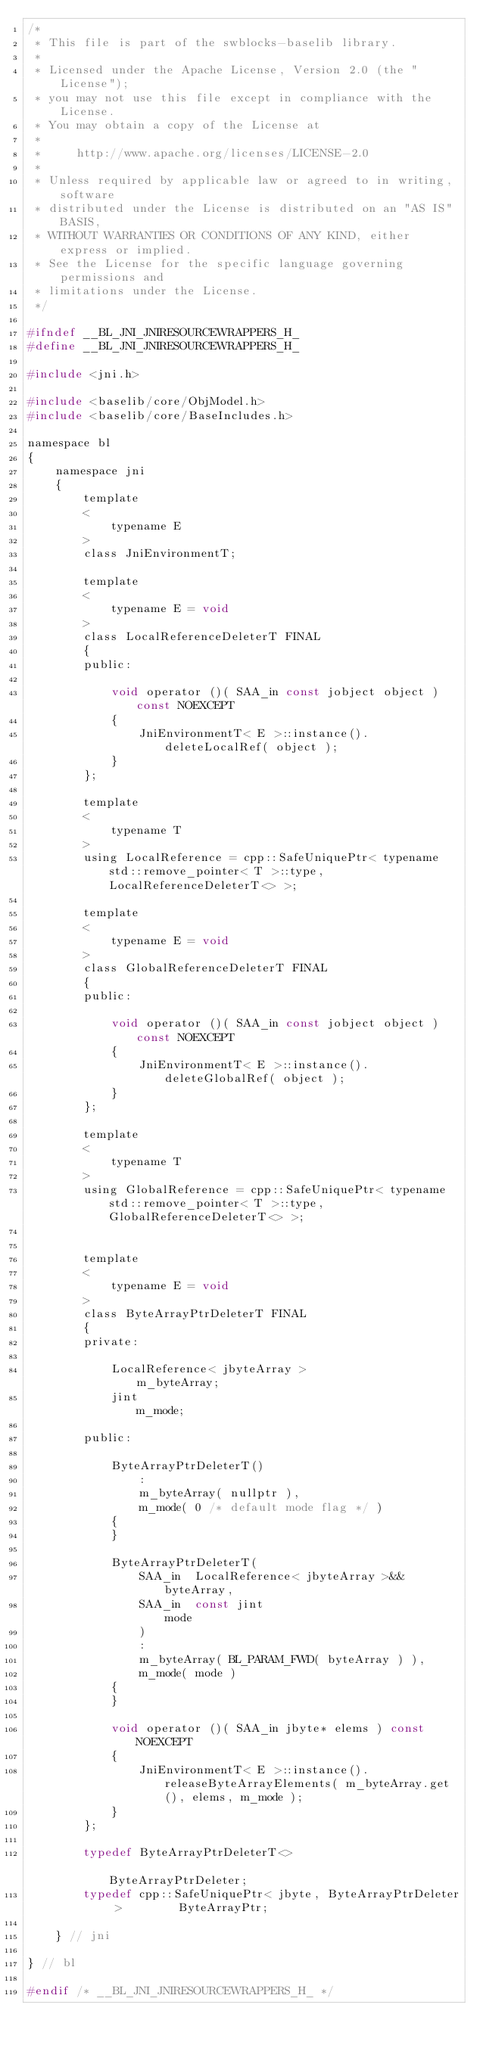Convert code to text. <code><loc_0><loc_0><loc_500><loc_500><_C_>/*
 * This file is part of the swblocks-baselib library.
 *
 * Licensed under the Apache License, Version 2.0 (the "License");
 * you may not use this file except in compliance with the License.
 * You may obtain a copy of the License at
 *
 *     http://www.apache.org/licenses/LICENSE-2.0
 *
 * Unless required by applicable law or agreed to in writing, software
 * distributed under the License is distributed on an "AS IS" BASIS,
 * WITHOUT WARRANTIES OR CONDITIONS OF ANY KIND, either express or implied.
 * See the License for the specific language governing permissions and
 * limitations under the License.
 */

#ifndef __BL_JNI_JNIRESOURCEWRAPPERS_H_
#define __BL_JNI_JNIRESOURCEWRAPPERS_H_

#include <jni.h>

#include <baselib/core/ObjModel.h>
#include <baselib/core/BaseIncludes.h>

namespace bl
{
    namespace jni
    {
        template
        <
            typename E
        >
        class JniEnvironmentT;

        template
        <
            typename E = void
        >
        class LocalReferenceDeleterT FINAL
        {
        public:

            void operator ()( SAA_in const jobject object ) const NOEXCEPT
            {
                JniEnvironmentT< E >::instance().deleteLocalRef( object );
            }
        };

        template
        <
            typename T
        >
        using LocalReference = cpp::SafeUniquePtr< typename std::remove_pointer< T >::type, LocalReferenceDeleterT<> >;

        template
        <
            typename E = void
        >
        class GlobalReferenceDeleterT FINAL
        {
        public:

            void operator ()( SAA_in const jobject object ) const NOEXCEPT
            {
                JniEnvironmentT< E >::instance().deleteGlobalRef( object );
            }
        };

        template
        <
            typename T
        >
        using GlobalReference = cpp::SafeUniquePtr< typename std::remove_pointer< T >::type, GlobalReferenceDeleterT<> >;


        template
        <
            typename E = void
        >
        class ByteArrayPtrDeleterT FINAL
        {
        private:

            LocalReference< jbyteArray >                    m_byteArray;
            jint                                            m_mode;

        public:

            ByteArrayPtrDeleterT()
                :
                m_byteArray( nullptr ),
                m_mode( 0 /* default mode flag */ )
            {
            }

            ByteArrayPtrDeleterT(
                SAA_in  LocalReference< jbyteArray >&&      byteArray,
                SAA_in  const jint                          mode
                )
                :
                m_byteArray( BL_PARAM_FWD( byteArray ) ),
                m_mode( mode )
            {
            }

            void operator ()( SAA_in jbyte* elems ) const NOEXCEPT
            {
                JniEnvironmentT< E >::instance().releaseByteArrayElements( m_byteArray.get(), elems, m_mode );
            }
        };

        typedef ByteArrayPtrDeleterT<>                                  ByteArrayPtrDeleter;
        typedef cpp::SafeUniquePtr< jbyte, ByteArrayPtrDeleter >        ByteArrayPtr;

    } // jni

} // bl

#endif /* __BL_JNI_JNIRESOURCEWRAPPERS_H_ */
</code> 